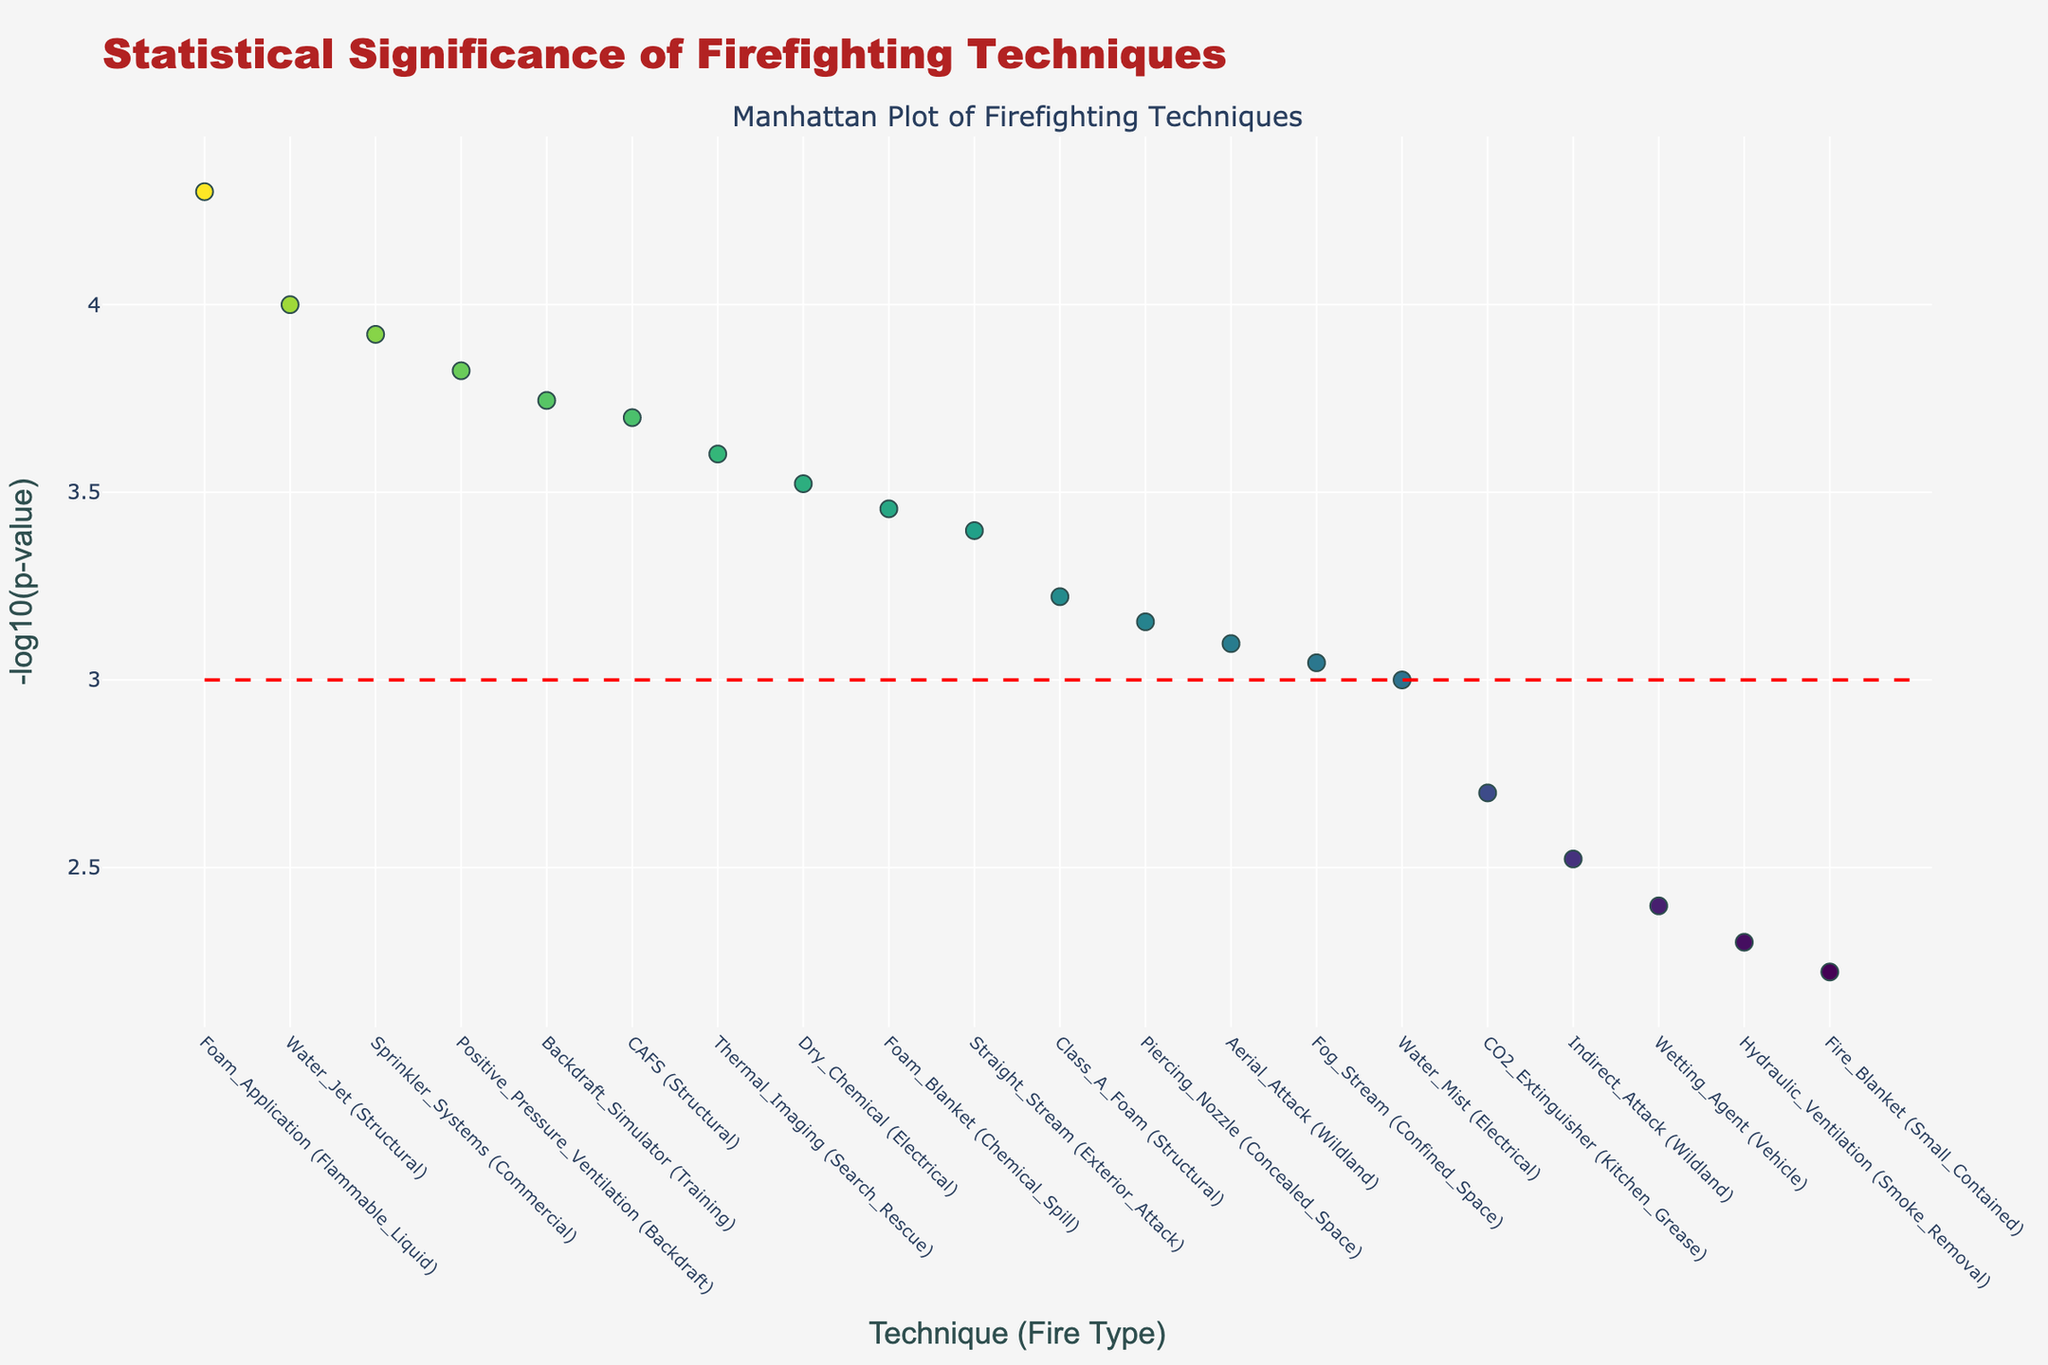What is the title of the plot? The title of the plot can be found at the top center of the figure in a larger and bold font.
Answer: Statistical Significance of Firefighting Techniques How many techniques have a -log10(p-value) greater than 3? Look for the points above the red dashed threshold line at 3 on the y-axis and count them.
Answer: 10 Which technique has the highest statistical significance? The technique with the highest -log10(p-value) will be the point at the highest y-value.
Answer: Foam_Application (Flammable_Liquid) What is the y-axis title in the figure? The y-axis title is found along the vertical axis, typically rotated 90 degrees.
Answer: -log10(p-value) How does the p-value of the technique 'Sprinkler_Systems' compare to that of 'Class_A_Foam'? Compare the heights of the points corresponding to 'Sprinkler_Systems (Commercial)' and 'Class_A_Foam (Structural)' on the y-axis.
Answer: Sprinkler_Systems is more significant Identify a technique used for structural fires and provide its statistical significance. Look for the techniques labeled with (Structural) and note their -log10(p-value). One example is 'Water_Jet (Structural)'.
Answer: -log10(p-value) = 4 What is the color scheme used in the figure? The colors for the markers follow a gradient, typically shown on the right or inferred by color difference.
Answer: Viridis Is 'Foam_Blanket' statistically more significant than 'Fog_Stream'? Compare the y-values of 'Foam_Blanket (Chemical_Spill)' and 'Fog_Stream (Confined_Space)'.
Answer: Yes, Foam_Blanket is more significant Which technique for wildland fires has a higher significance, 'Aerial_Attack' or 'Indirect_Attack'? Observe the y-values for 'Aerial_Attack (Wildland)' and 'Indirect_Attack (Wildland)' points.
Answer: Aerial_Attack 